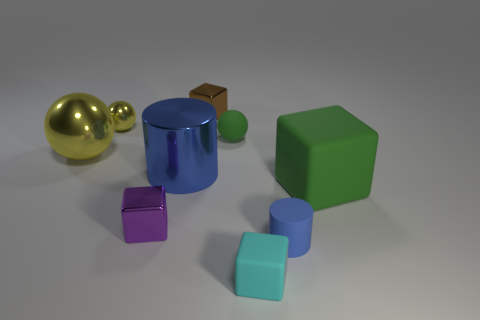How many yellow spheres must be subtracted to get 1 yellow spheres? 1 Subtract all blocks. How many objects are left? 5 Subtract all big yellow metal objects. Subtract all cyan matte things. How many objects are left? 7 Add 7 big metal spheres. How many big metal spheres are left? 8 Add 5 brown things. How many brown things exist? 6 Subtract 1 blue cylinders. How many objects are left? 8 